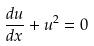Convert formula to latex. <formula><loc_0><loc_0><loc_500><loc_500>\frac { d u } { d x } + u ^ { 2 } = 0</formula> 